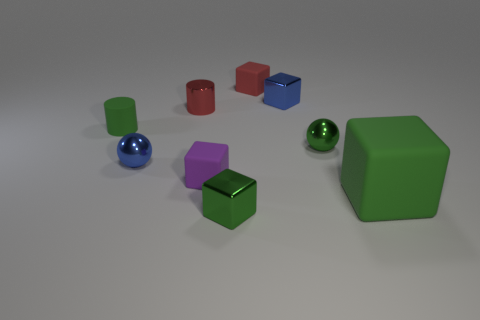What number of objects are big gray cubes or tiny objects in front of the tiny red rubber block?
Your response must be concise. 7. Is the color of the large object the same as the tiny shiny cylinder?
Keep it short and to the point. No. Are there any small gray spheres made of the same material as the purple cube?
Provide a short and direct response. No. There is a large thing that is the same shape as the small red matte object; what color is it?
Ensure brevity in your answer.  Green. Is the material of the red block the same as the cylinder that is behind the small green matte cylinder?
Your response must be concise. No. What is the shape of the blue object to the right of the metal block in front of the large green matte cube?
Keep it short and to the point. Cube. There is a green matte object that is right of the red cube; does it have the same size as the red cylinder?
Your answer should be compact. No. How many other objects are the same shape as the tiny green matte object?
Provide a succinct answer. 1. Does the matte block that is in front of the tiny purple object have the same color as the matte cylinder?
Your response must be concise. Yes. Is there a ball of the same color as the metallic cylinder?
Keep it short and to the point. No. 